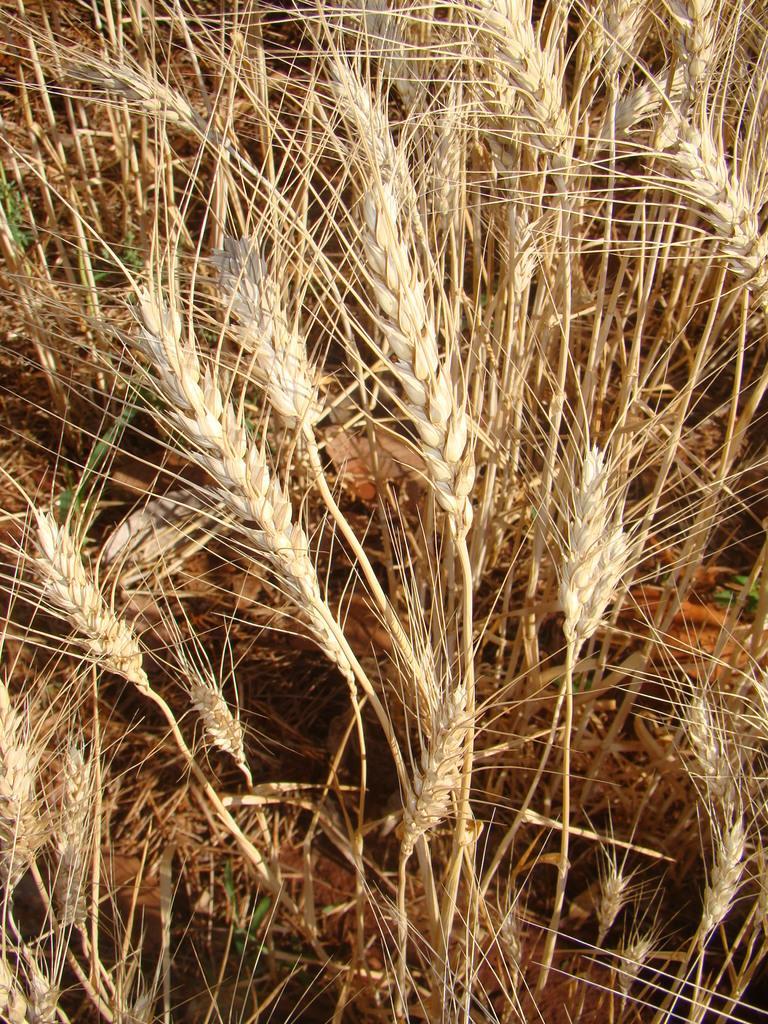In one or two sentences, can you explain what this image depicts? In this image there are plants of wheat. 